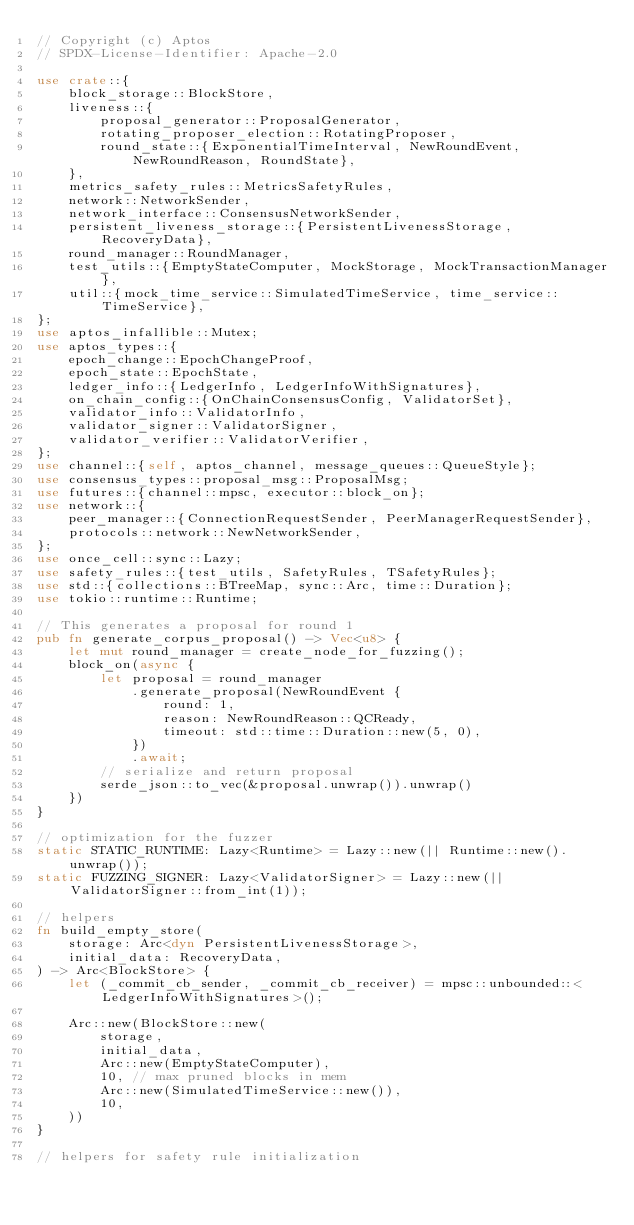<code> <loc_0><loc_0><loc_500><loc_500><_Rust_>// Copyright (c) Aptos
// SPDX-License-Identifier: Apache-2.0

use crate::{
    block_storage::BlockStore,
    liveness::{
        proposal_generator::ProposalGenerator,
        rotating_proposer_election::RotatingProposer,
        round_state::{ExponentialTimeInterval, NewRoundEvent, NewRoundReason, RoundState},
    },
    metrics_safety_rules::MetricsSafetyRules,
    network::NetworkSender,
    network_interface::ConsensusNetworkSender,
    persistent_liveness_storage::{PersistentLivenessStorage, RecoveryData},
    round_manager::RoundManager,
    test_utils::{EmptyStateComputer, MockStorage, MockTransactionManager},
    util::{mock_time_service::SimulatedTimeService, time_service::TimeService},
};
use aptos_infallible::Mutex;
use aptos_types::{
    epoch_change::EpochChangeProof,
    epoch_state::EpochState,
    ledger_info::{LedgerInfo, LedgerInfoWithSignatures},
    on_chain_config::{OnChainConsensusConfig, ValidatorSet},
    validator_info::ValidatorInfo,
    validator_signer::ValidatorSigner,
    validator_verifier::ValidatorVerifier,
};
use channel::{self, aptos_channel, message_queues::QueueStyle};
use consensus_types::proposal_msg::ProposalMsg;
use futures::{channel::mpsc, executor::block_on};
use network::{
    peer_manager::{ConnectionRequestSender, PeerManagerRequestSender},
    protocols::network::NewNetworkSender,
};
use once_cell::sync::Lazy;
use safety_rules::{test_utils, SafetyRules, TSafetyRules};
use std::{collections::BTreeMap, sync::Arc, time::Duration};
use tokio::runtime::Runtime;

// This generates a proposal for round 1
pub fn generate_corpus_proposal() -> Vec<u8> {
    let mut round_manager = create_node_for_fuzzing();
    block_on(async {
        let proposal = round_manager
            .generate_proposal(NewRoundEvent {
                round: 1,
                reason: NewRoundReason::QCReady,
                timeout: std::time::Duration::new(5, 0),
            })
            .await;
        // serialize and return proposal
        serde_json::to_vec(&proposal.unwrap()).unwrap()
    })
}

// optimization for the fuzzer
static STATIC_RUNTIME: Lazy<Runtime> = Lazy::new(|| Runtime::new().unwrap());
static FUZZING_SIGNER: Lazy<ValidatorSigner> = Lazy::new(|| ValidatorSigner::from_int(1));

// helpers
fn build_empty_store(
    storage: Arc<dyn PersistentLivenessStorage>,
    initial_data: RecoveryData,
) -> Arc<BlockStore> {
    let (_commit_cb_sender, _commit_cb_receiver) = mpsc::unbounded::<LedgerInfoWithSignatures>();

    Arc::new(BlockStore::new(
        storage,
        initial_data,
        Arc::new(EmptyStateComputer),
        10, // max pruned blocks in mem
        Arc::new(SimulatedTimeService::new()),
        10,
    ))
}

// helpers for safety rule initialization</code> 